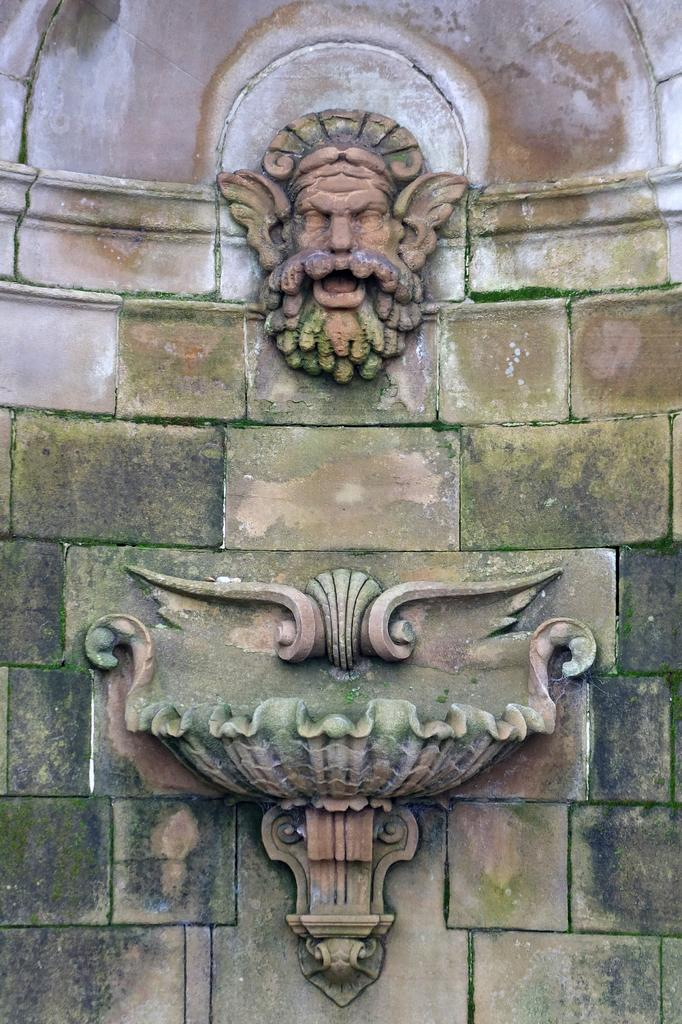What type of artwork is featured in the image? There is a stone carving and a statue in the image. Where are the stone carving and statue located? Both the stone carving and statue are on a wall. Can you describe the stone carving in the image? Unfortunately, the facts provided do not give a detailed description of the stone carving. What type of grape is being used to play the drum in the image? There is no grape or drum present in the image. How can we help the statue in the image? The image does not indicate any need for help, as the statue is an inanimate object. 